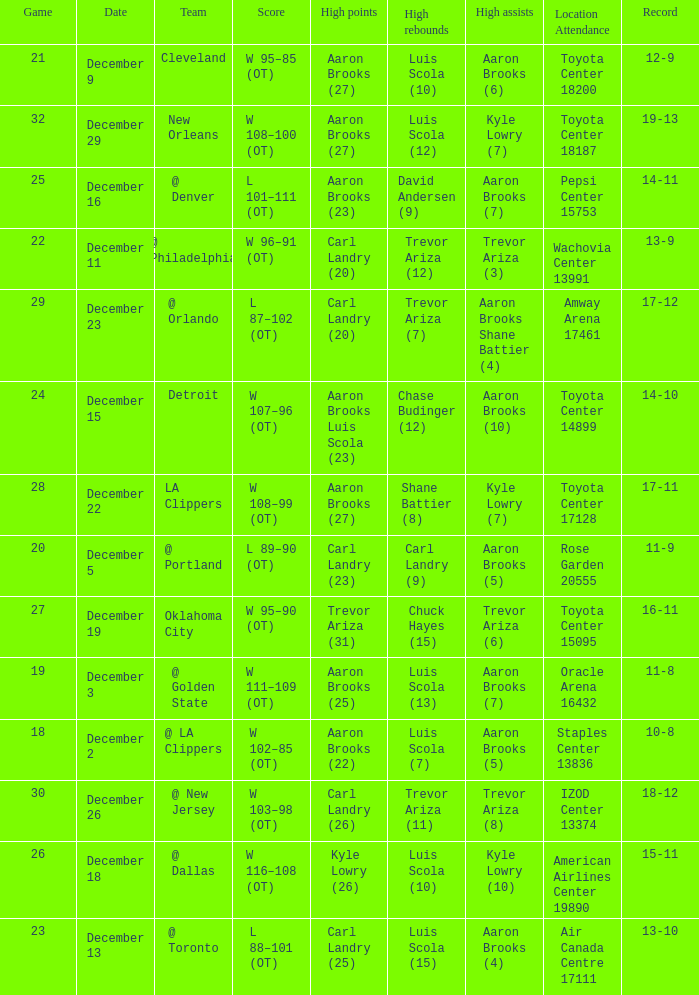What's the end score of the game where Shane Battier (8) did the high rebounds? W 108–99 (OT). 